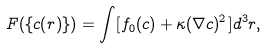<formula> <loc_0><loc_0><loc_500><loc_500>F ( \{ c ( { r } ) \} ) = \int [ f _ { 0 } ( c ) + \kappa ( \nabla c ) ^ { 2 } ] d ^ { 3 } { r } ,</formula> 